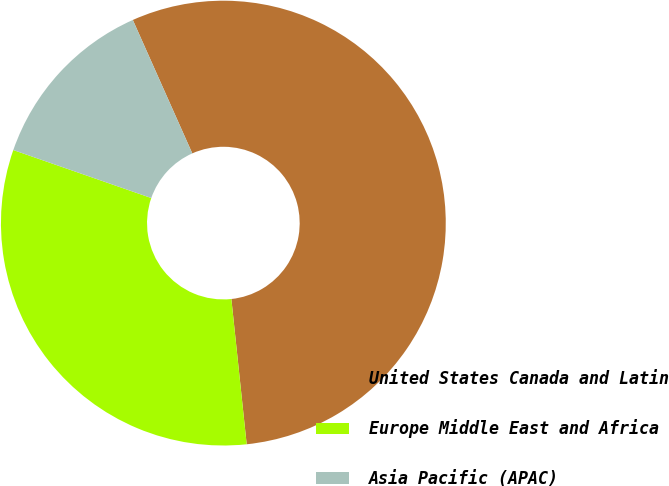Convert chart to OTSL. <chart><loc_0><loc_0><loc_500><loc_500><pie_chart><fcel>United States Canada and Latin<fcel>Europe Middle East and Africa<fcel>Asia Pacific (APAC)<nl><fcel>55.0%<fcel>32.0%<fcel>13.0%<nl></chart> 